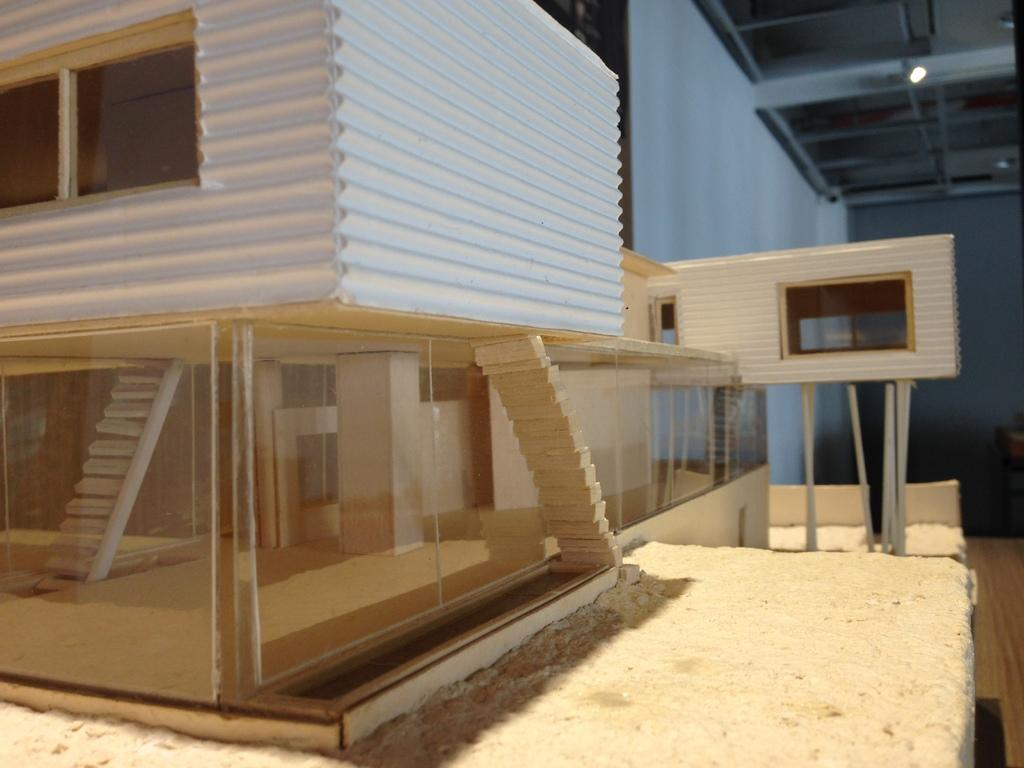What type of structure is visible in the image? There is a building in the image. What can be seen on the right side of the image? There is a shed and a wall on the right side of the image. Where is the light source located in the image? There is a light in the top right corner of the image. What type of lace can be seen on the bed in the image? There is no bed present in the image, so there is no lace to be seen. 